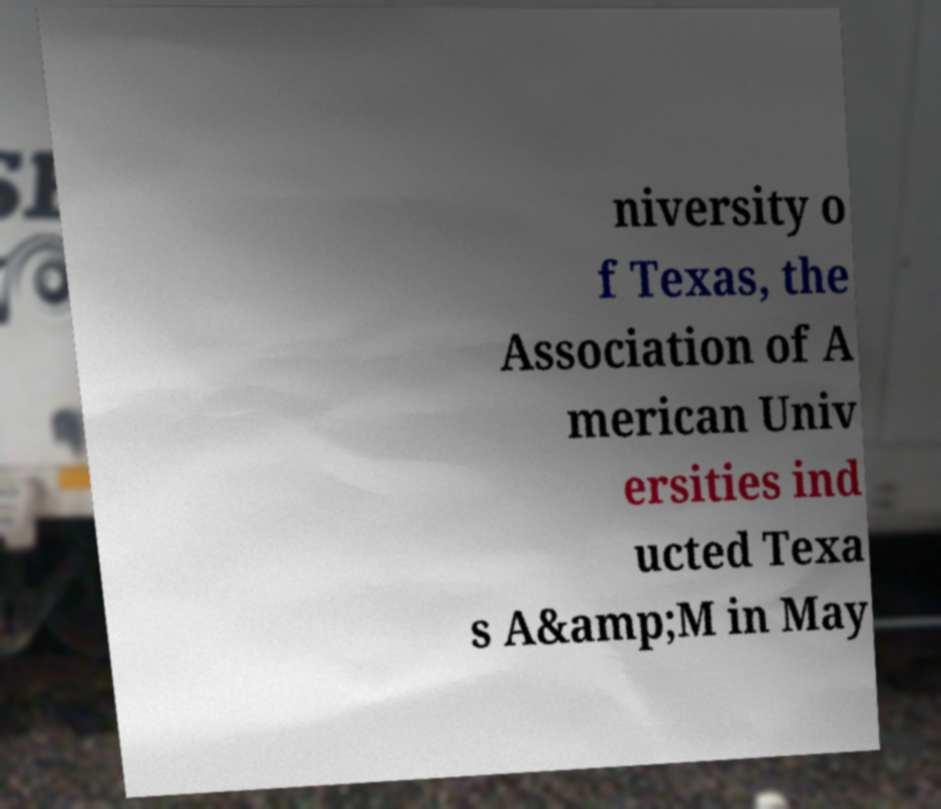Can you read and provide the text displayed in the image?This photo seems to have some interesting text. Can you extract and type it out for me? niversity o f Texas, the Association of A merican Univ ersities ind ucted Texa s A&amp;M in May 